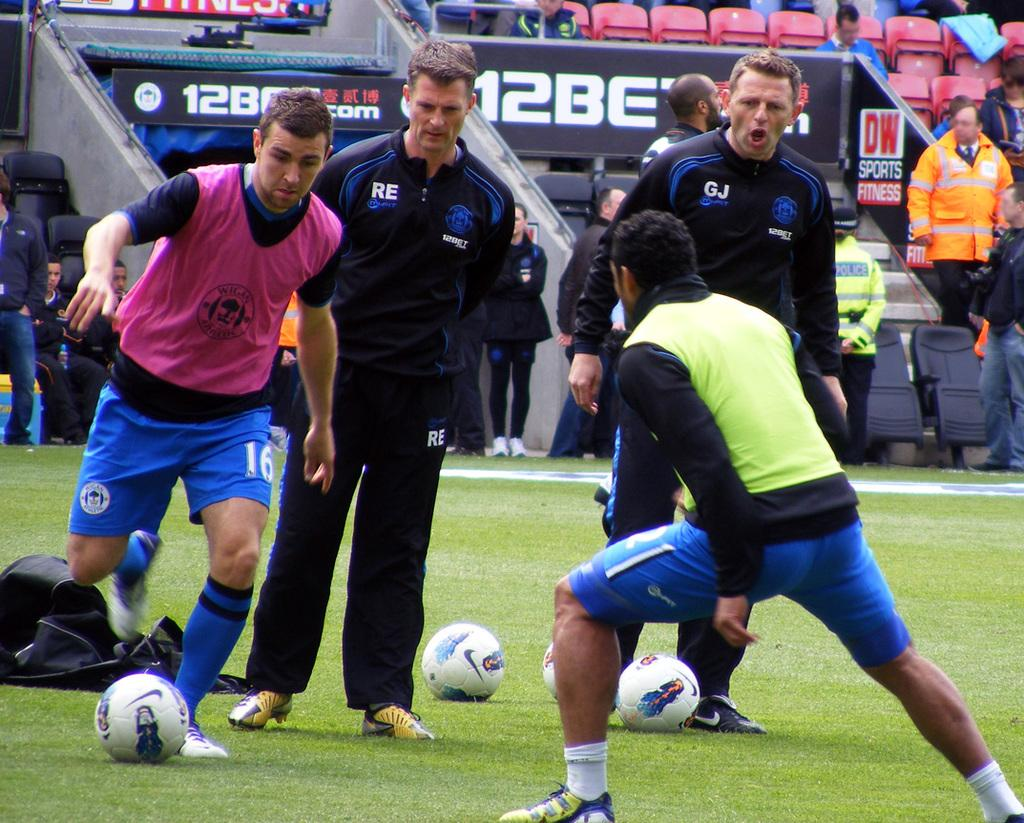What are the persons in the image doing? The persons in the image are playing with a ball on the ground. What can be seen in the background of the image? There are chairs visible in the background. Where are the persons standing in the image? The persons are standing on the ground. What color is the crayon used by the persons in the image? There is no crayon present in the image. How many legs can be seen on the persons in the image? The image does not show the legs of the persons, only their upper bodies and heads. 